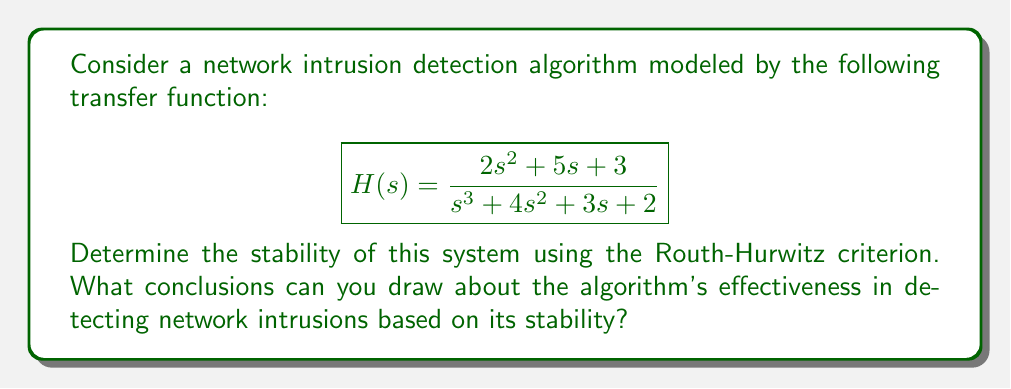Can you solve this math problem? To analyze the stability of the system using the Routh-Hurwitz criterion, we need to construct the Routh array and examine its first column for sign changes.

1. First, let's write out the characteristic equation:
   $$s^3 + 4s^2 + 3s + 2 = 0$$

2. Now, let's construct the Routh array:

   $$\begin{array}{c|c|c}
   s^3 & 1 & 3 \\
   s^2 & 4 & 2 \\
   s^1 & b_1 & 0 \\
   s^0 & b_2 & 0
   \end{array}$$

3. Calculate $b_1$:
   $$b_1 = \frac{4 \cdot 3 - 1 \cdot 2}{4} = \frac{10}{4} = 2.5$$

4. Calculate $b_2$:
   $$b_2 = \frac{2.5 \cdot 2 - 0}{2.5} = 2$$

5. The complete Routh array:

   $$\begin{array}{c|c|c}
   s^3 & 1 & 3 \\
   s^2 & 4 & 2 \\
   s^1 & 2.5 & 0 \\
   s^0 & 2 & 0
   \end{array}$$

6. Examine the first column for sign changes:
   There are no sign changes in the first column (1, 4, 2.5, 2).

According to the Routh-Hurwitz criterion, the system is stable if and only if all elements in the first column of the Routh array have the same sign (all positive or all negative). In this case, all elements are positive, indicating that the system is stable.

For a network intrusion detection algorithm, stability is crucial. A stable system ensures that the algorithm's response to input signals (network traffic patterns) remains bounded and doesn't oscillate uncontrollably. This stability suggests that the algorithm can consistently and reliably process network traffic data without becoming unstable or producing erratic results.

In the context of network security, a stable intrusion detection algorithm is more likely to:
1. Provide consistent performance over time
2. Avoid false positives due to internal instabilities
3. Maintain accuracy in detecting actual intrusions
4. Be more resilient to potential evasion techniques used by attackers

However, it's important to note that while stability is necessary for effective operation, it doesn't guarantee the algorithm's accuracy or effectiveness in detecting all types of intrusions. Other factors such as the algorithm's sensitivity, specificity, and ability to adapt to new threat patterns are also crucial for overall effectiveness.
Answer: The system is stable according to the Routh-Hurwitz criterion, as there are no sign changes in the first column of the Routh array. This stability suggests that the network intrusion detection algorithm can provide consistent and reliable performance in processing network traffic data, which is favorable for maintaining accurate threat detection capabilities. 